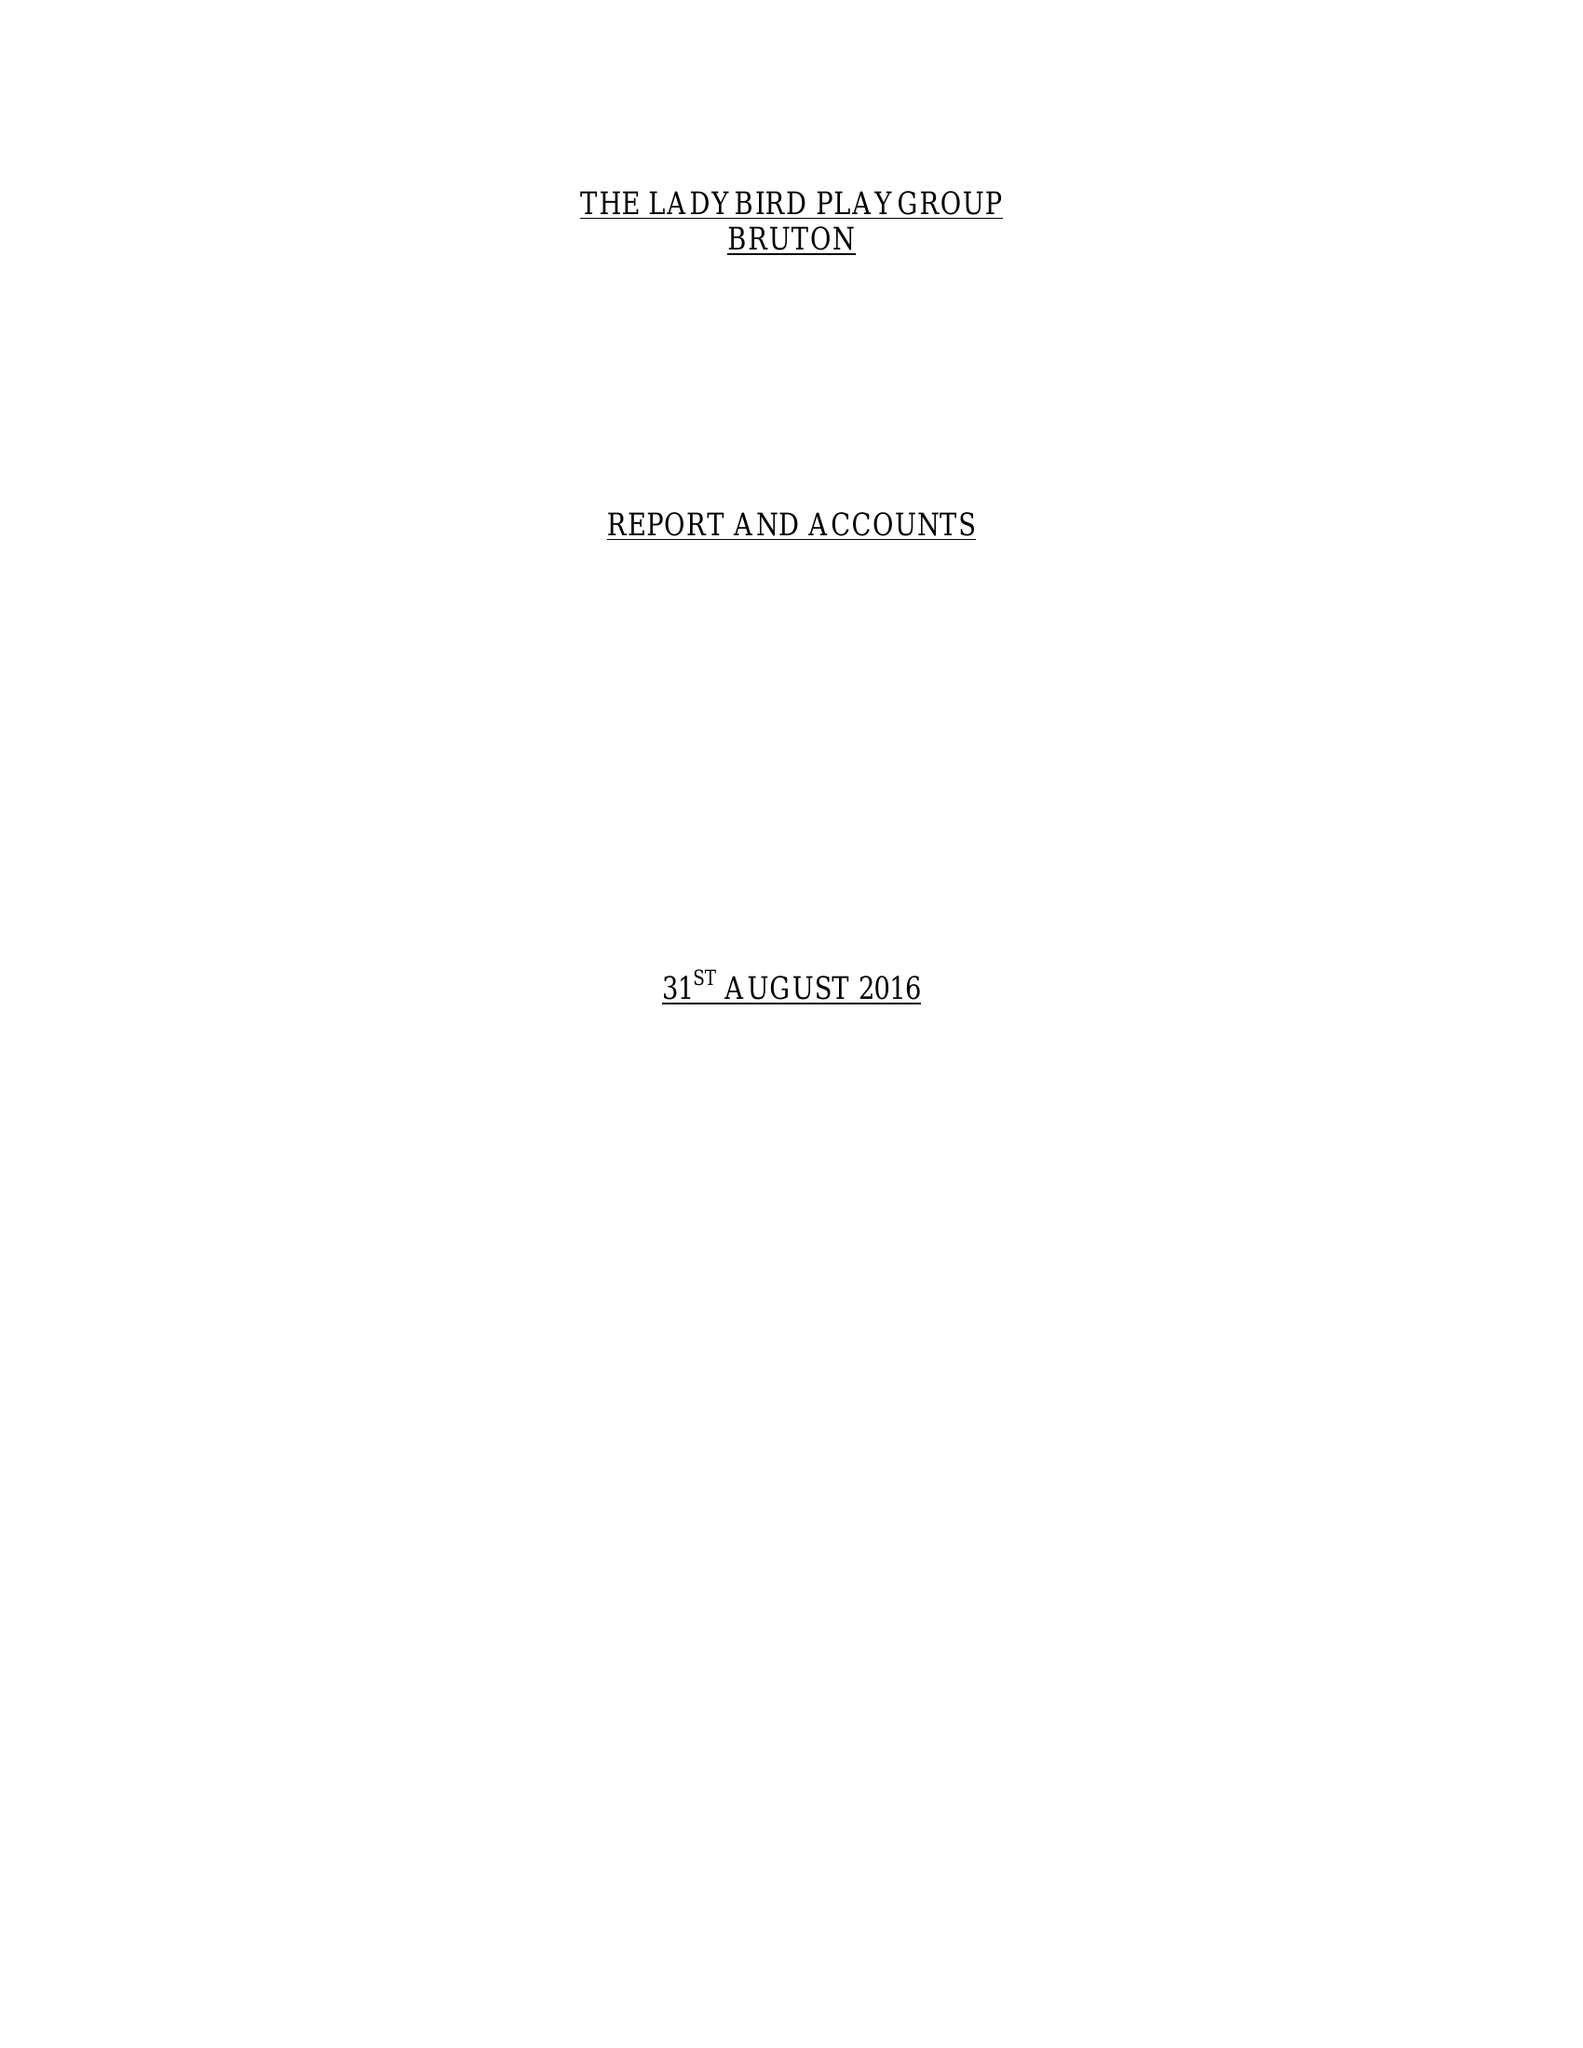What is the value for the charity_number?
Answer the question using a single word or phrase. 1038847 